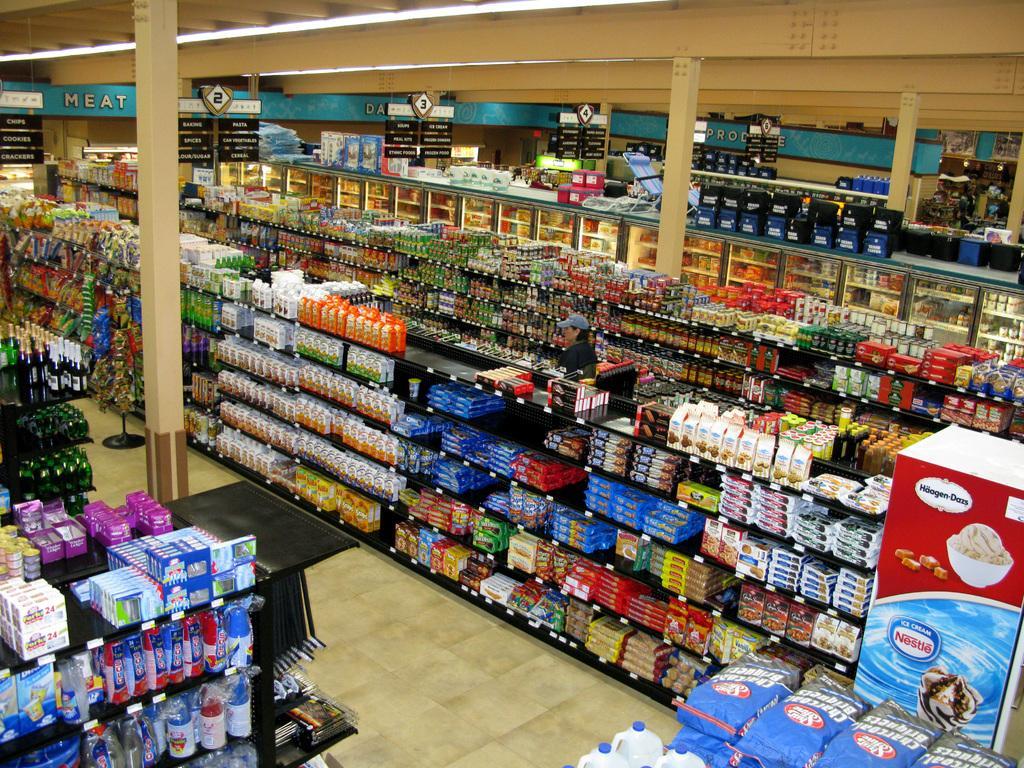Could you give a brief overview of what you see in this image? As we can see in the image, there is a supermarket and in supermarket there are so many racks. In racks there are different types of items and the floor is in cream color. 